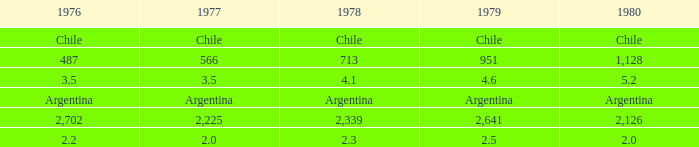Would you be able to parse every entry in this table? {'header': ['1976', '1977', '1978', '1979', '1980'], 'rows': [['Chile', 'Chile', 'Chile', 'Chile', 'Chile'], ['487', '566', '713', '951', '1,128'], ['3.5', '3.5', '4.1', '4.6', '5.2'], ['Argentina', 'Argentina', 'Argentina', 'Argentina', 'Argentina'], ['2,702', '2,225', '2,339', '2,641', '2,126'], ['2.2', '2.0', '2.3', '2.5', '2.0']]} 1? 3.5. 